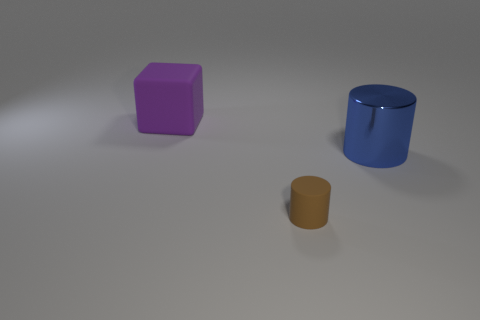Add 2 tiny brown metal cylinders. How many objects exist? 5 Subtract all blocks. How many objects are left? 2 Add 1 large green metal cubes. How many large green metal cubes exist? 1 Subtract 0 green blocks. How many objects are left? 3 Subtract all large red metallic blocks. Subtract all brown matte things. How many objects are left? 2 Add 3 big blue things. How many big blue things are left? 4 